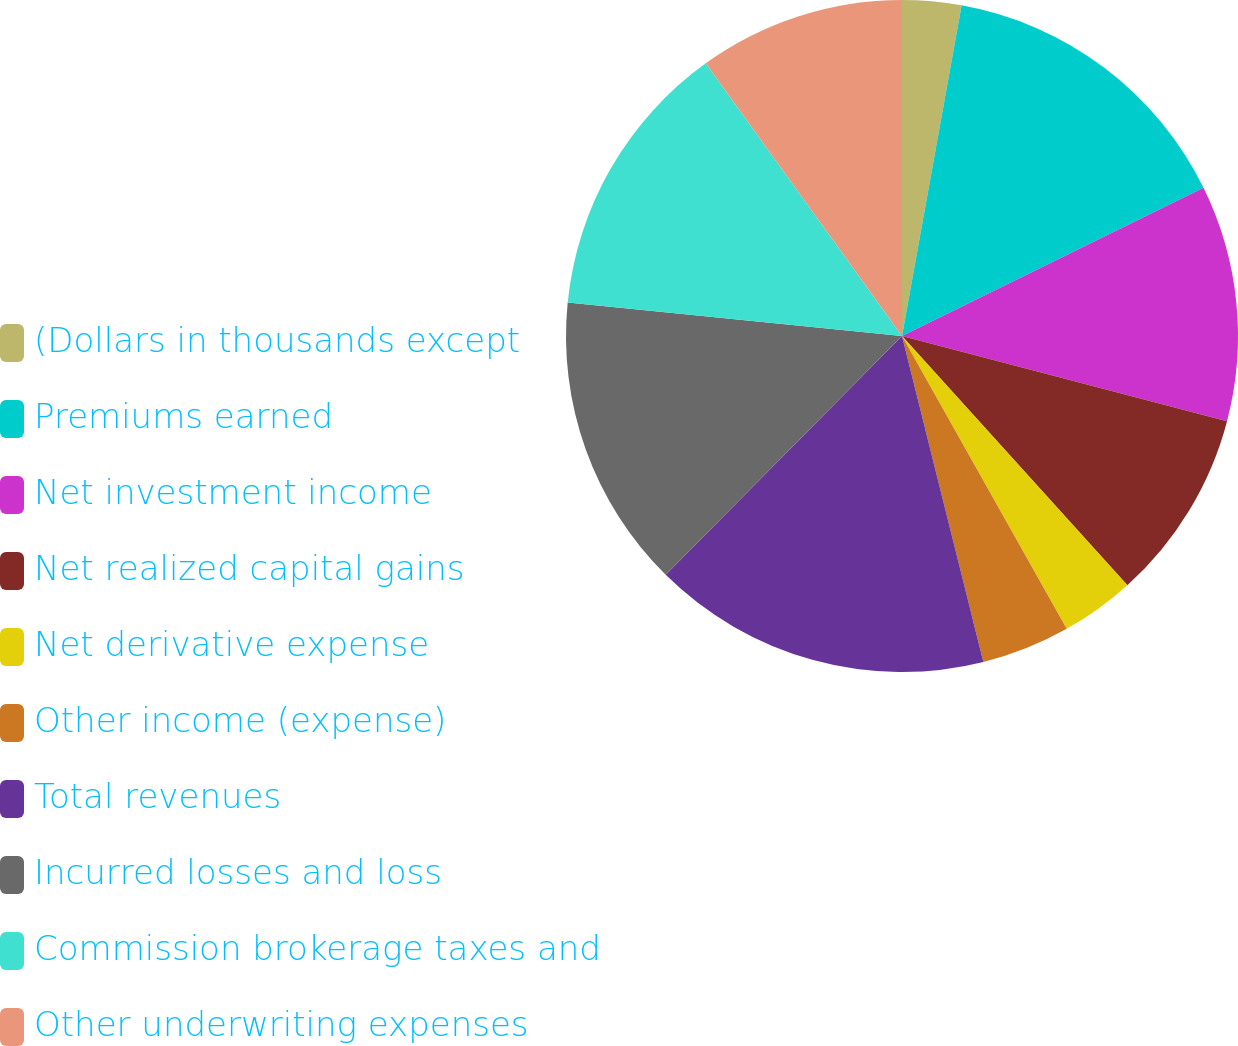Convert chart to OTSL. <chart><loc_0><loc_0><loc_500><loc_500><pie_chart><fcel>(Dollars in thousands except<fcel>Premiums earned<fcel>Net investment income<fcel>Net realized capital gains<fcel>Net derivative expense<fcel>Other income (expense)<fcel>Total revenues<fcel>Incurred losses and loss<fcel>Commission brokerage taxes and<fcel>Other underwriting expenses<nl><fcel>2.84%<fcel>14.89%<fcel>11.35%<fcel>9.22%<fcel>3.55%<fcel>4.26%<fcel>16.31%<fcel>14.18%<fcel>13.48%<fcel>9.93%<nl></chart> 